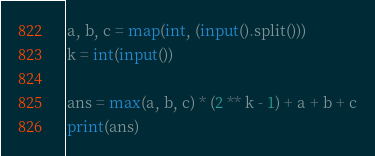<code> <loc_0><loc_0><loc_500><loc_500><_Python_>a, b, c = map(int, (input().split()))
k = int(input())

ans = max(a, b, c) * (2 ** k - 1) + a + b + c
print(ans)</code> 